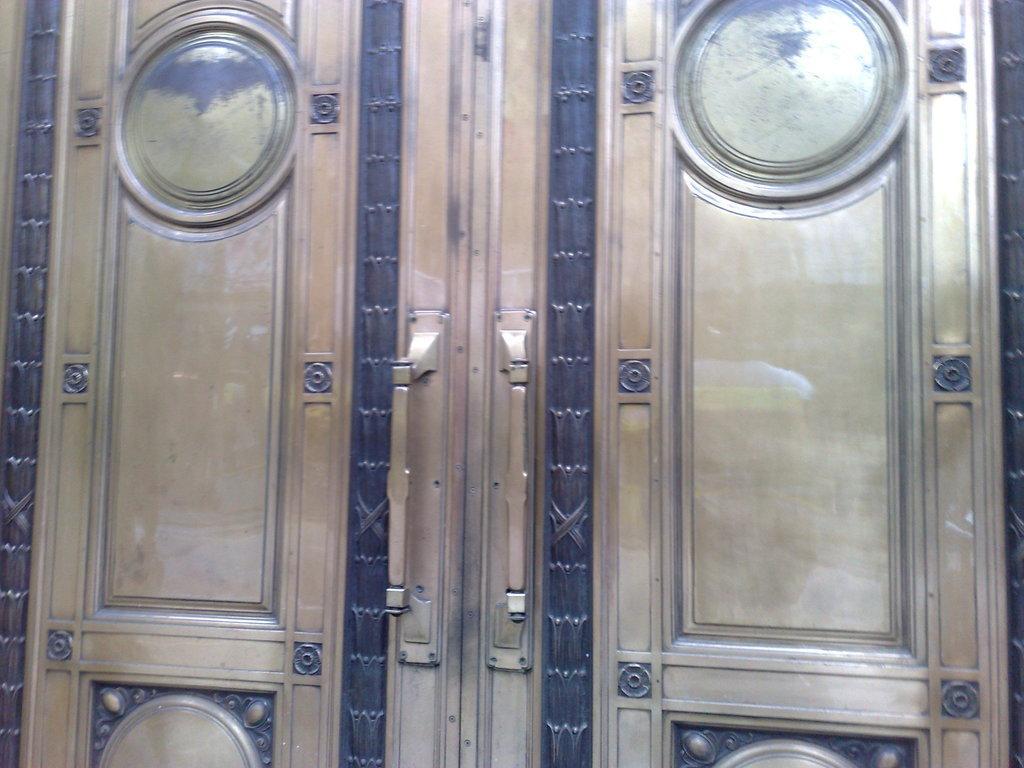Please provide a concise description of this image. In this picture I can see there is a door and it has a metal handle and a there is a metal frame on the door. 